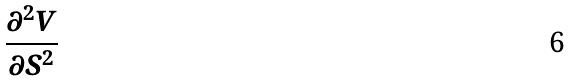<formula> <loc_0><loc_0><loc_500><loc_500>\frac { \partial ^ { 2 } V } { \partial S ^ { 2 } }</formula> 